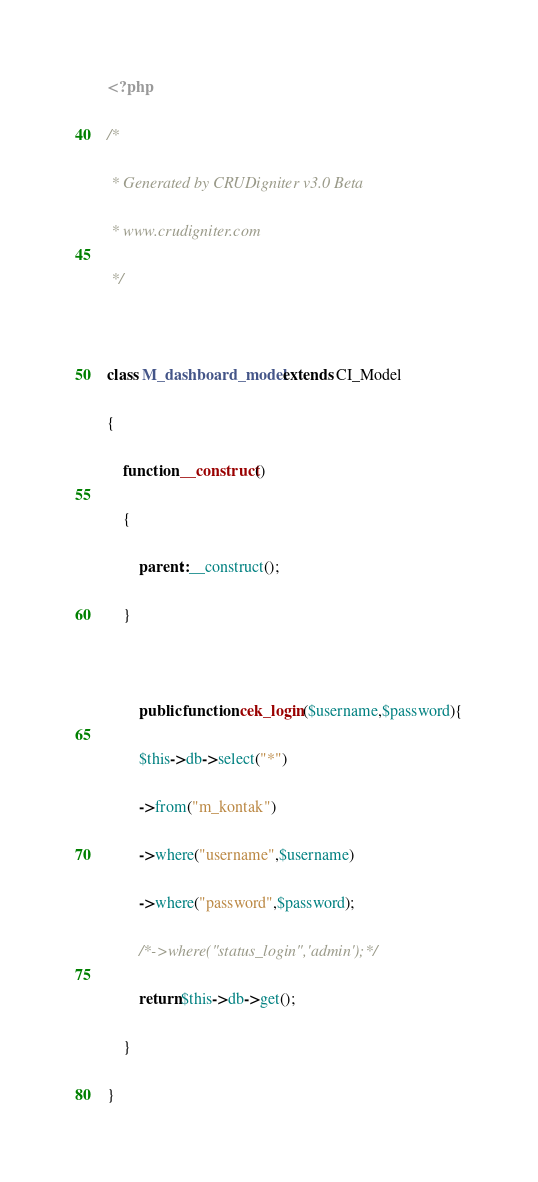Convert code to text. <code><loc_0><loc_0><loc_500><loc_500><_PHP_><?php
/* 
 * Generated by CRUDigniter v3.0 Beta 
 * www.crudigniter.com
 */
 
class M_dashboard_model extends CI_Model
{
    function __construct()
    {
        parent::__construct();
    }
    
        public function cek_login($username,$password){
        $this->db->select("*")
        ->from("m_kontak")
        ->where("username",$username)
        ->where("password",$password);
        /*->where("status_login",'admin');*/
        return $this->db->get();
    }
}
</code> 